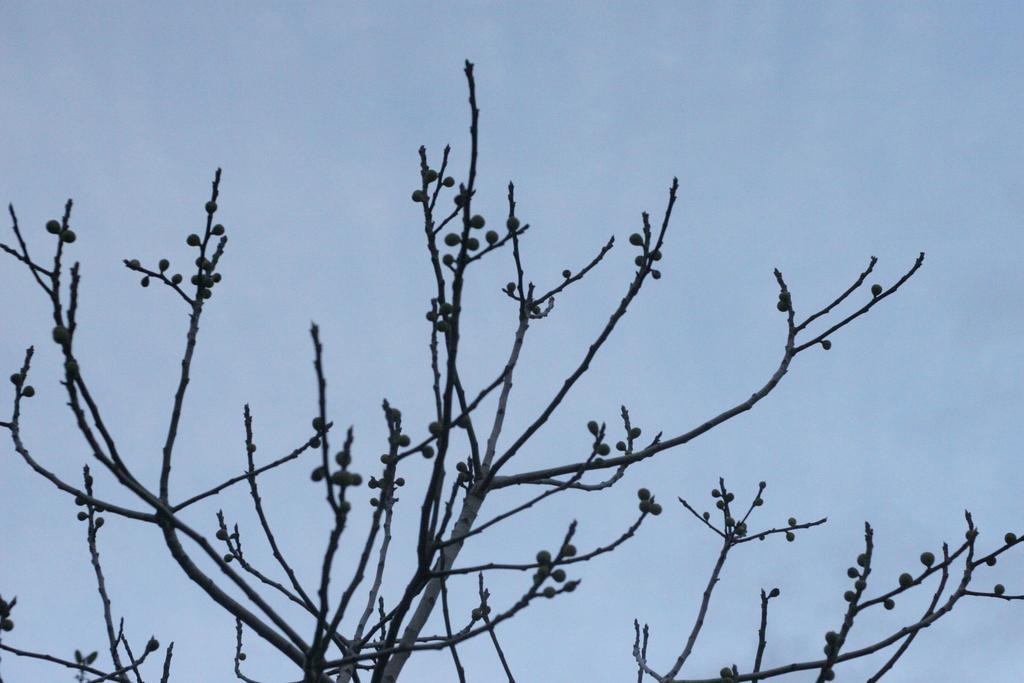What type of plant can be seen in the image? There is a tree in the image. Are there any fruits visible on the tree? The image might show fruits on the tree. What is visible at the top of the image? The sky is visible at the top of the image. Where is the dock located in the image? There is no dock present in the image. How many years has the tramp been living in the tree? There is no tramp present in the image, so it is not possible to determine how many years they have been living in the tree. 